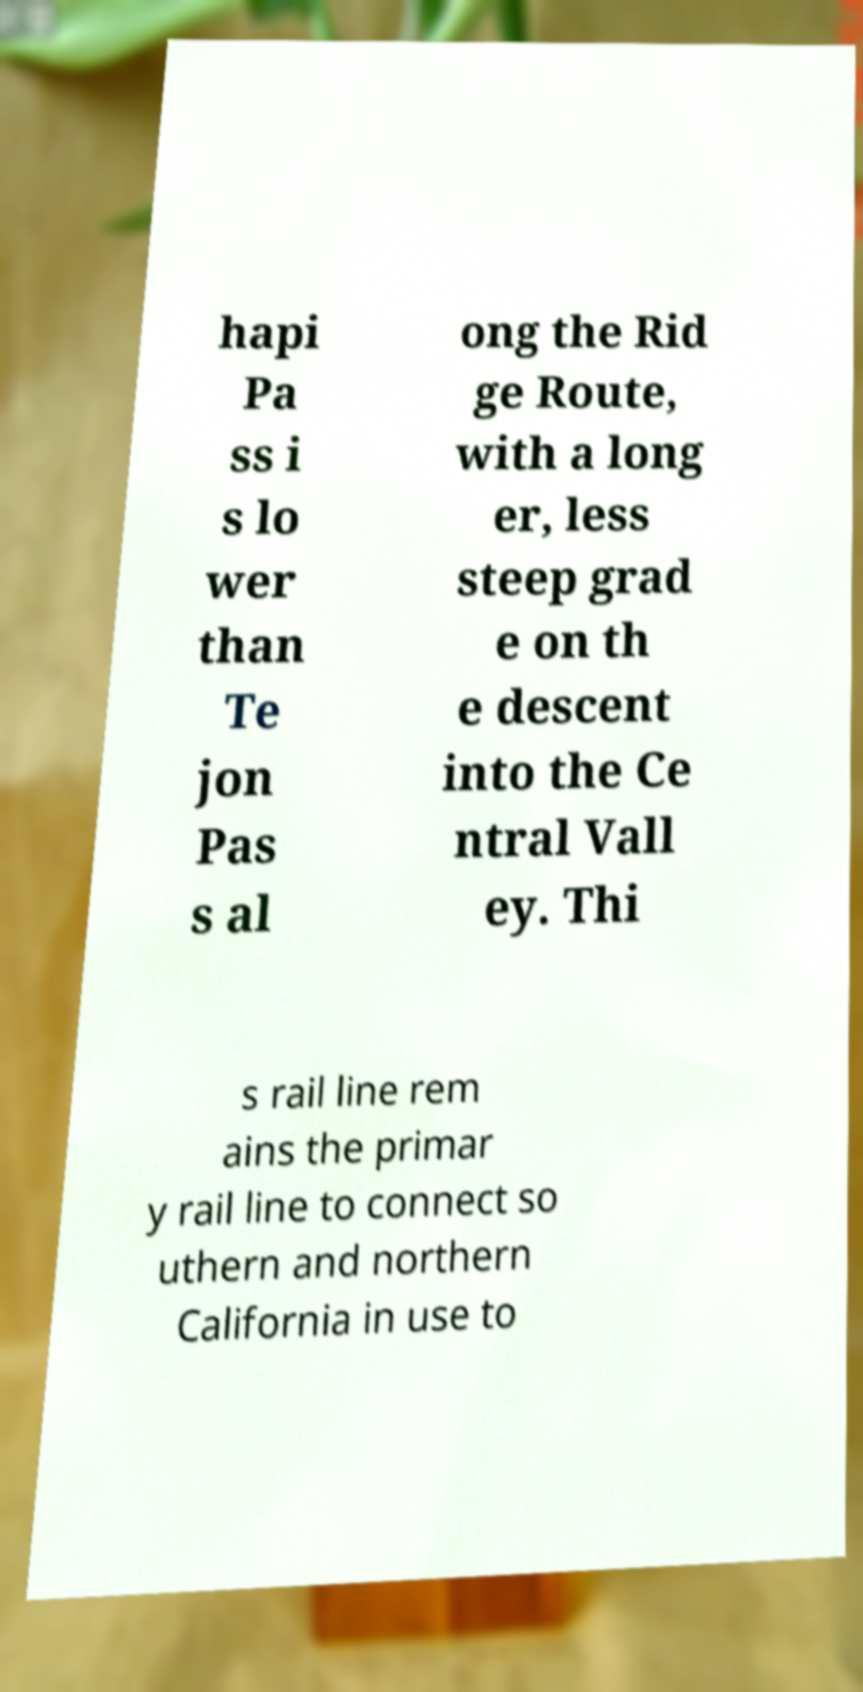Could you extract and type out the text from this image? hapi Pa ss i s lo wer than Te jon Pas s al ong the Rid ge Route, with a long er, less steep grad e on th e descent into the Ce ntral Vall ey. Thi s rail line rem ains the primar y rail line to connect so uthern and northern California in use to 